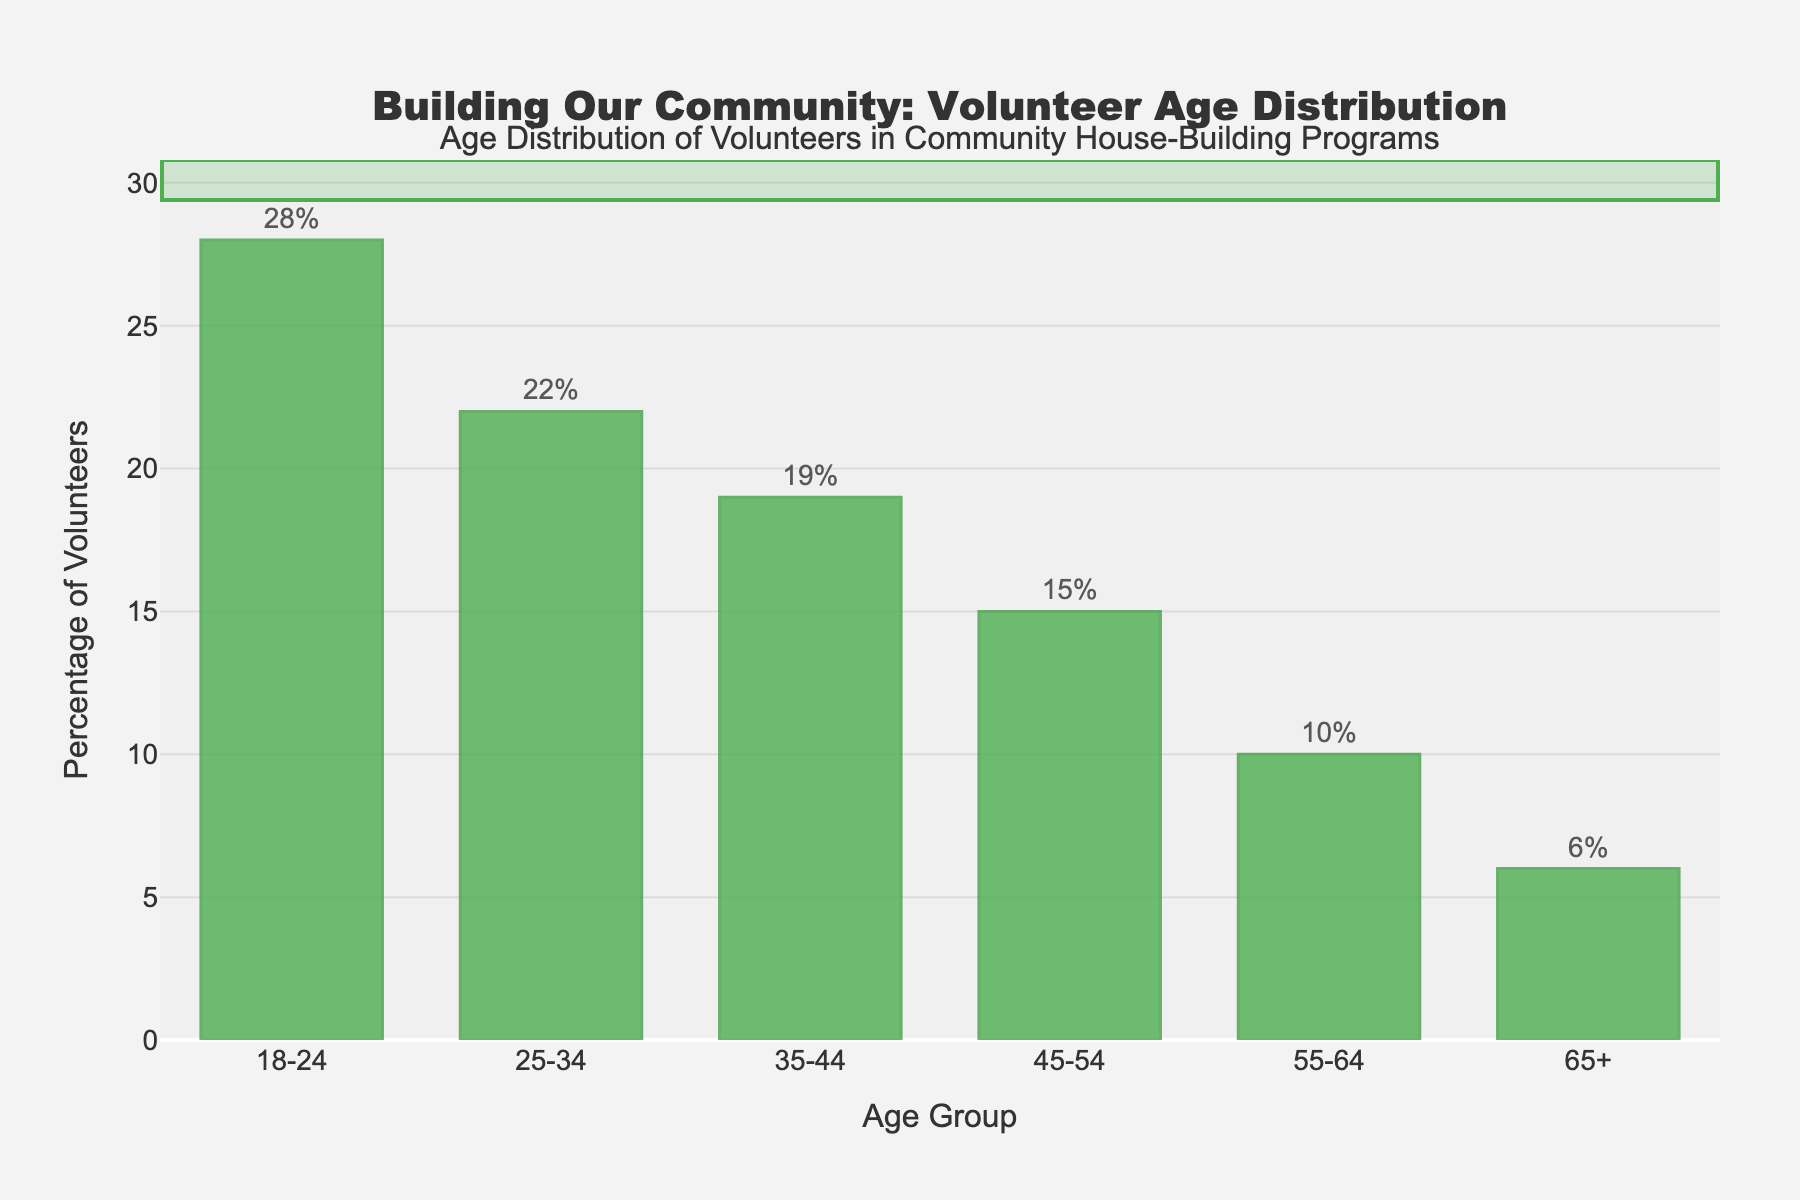what is the percentage difference between the most and least represented age groups? The most represented age group is 18-24 with 28%, and the least represented age group is 65+ with 6%. To find the percentage difference, subtract the smaller value from the larger value: 28% - 6% = 22%.
Answer: 22% Which age group has the highest percentage of volunteers? By looking at the height of the bars, the 18-24 age group has the highest bar, indicating the highest percentage of volunteers.
Answer: 18-24 What is the combined percentage of volunteers for the age groups 35-44 and 45-54? The percentage for 35-44 is 19% and for 45-54 is 15%. Adding these together: 19% + 15% = 34%.
Answer: 34% Are there more volunteers in the age group 25-34 or 55-64? By comparing the heights of the bars, the 25-34 age group is higher than the 55-64 age group. The percentages are 22% for 25-34 and 10% for 55-64.
Answer: 25-34 What is the average percentage of volunteers across all the age groups? The percentages are: 28, 22, 19, 15, 10, and 6. Add these values to get the sum: 28 + 22 + 19 + 15 + 10 + 6 = 100. Divide by the number of age groups (6): 100 / 6 ≈ 16.67%.
Answer: 16.67% Which age groups combined make up more than 50% of the volunteers? Start adding the percentages from the highest: 18-24 (28%), 25-34 (22%). Together: 28% + 22% = 50%. These two groups alone make up more than 50%.
Answer: 18-24 and 25-34 Is the percentage of volunteers in the 45-54 age group greater than the percentage in the 55-64 age group? Compare the heights of the bars: the 45-54 (15%) bar is higher than the 55-64 (10%) bar.
Answer: Yes By what percentage is the 25-34 age group's volunteer percentage lower than the 18-24 age group's? The percentage for 18-24 is 28% and for 25-34 is 22%. Subtract 22% from 28%: 28% - 22% = 6%.
Answer: 6% What is the percentage share of volunteers aged 55+ (55-64 and 65+ combined)? The percentages for 55-64 and 65+ are 10% and 6%, respectively. Add them together: 10% + 6% = 16%.
Answer: 16% Which age group shows a volunteer percentage that is exactly half of the highest age group's percentage? The highest percentage is for the 18-24 age group at 28%. Half of 28% is 14%. The closest percentage is 15% for the 45-54 age group, slightly more than half but the closest match.
Answer: 45-54 